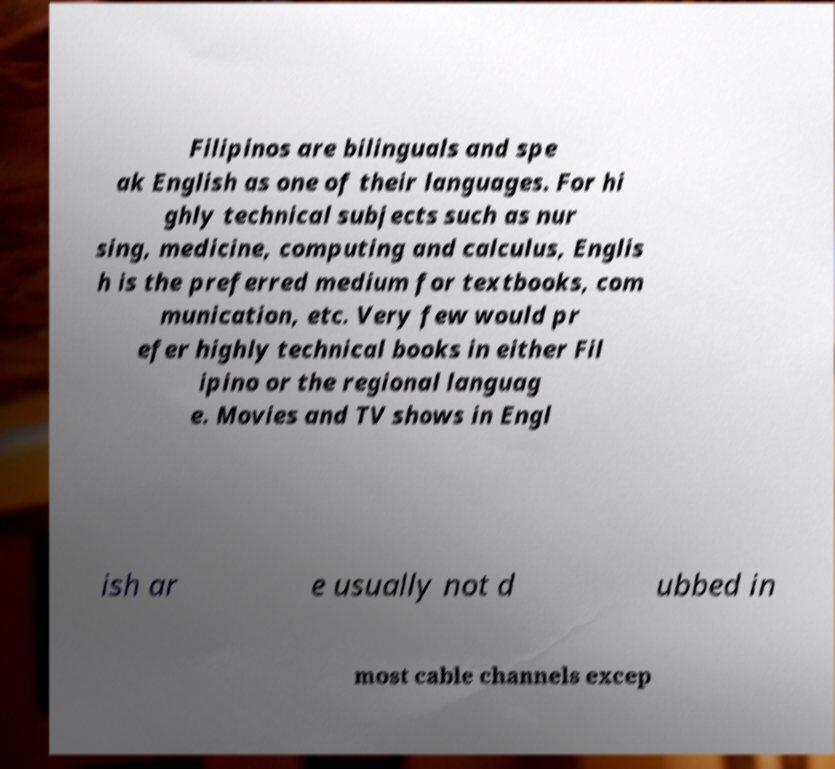I need the written content from this picture converted into text. Can you do that? Filipinos are bilinguals and spe ak English as one of their languages. For hi ghly technical subjects such as nur sing, medicine, computing and calculus, Englis h is the preferred medium for textbooks, com munication, etc. Very few would pr efer highly technical books in either Fil ipino or the regional languag e. Movies and TV shows in Engl ish ar e usually not d ubbed in most cable channels excep 